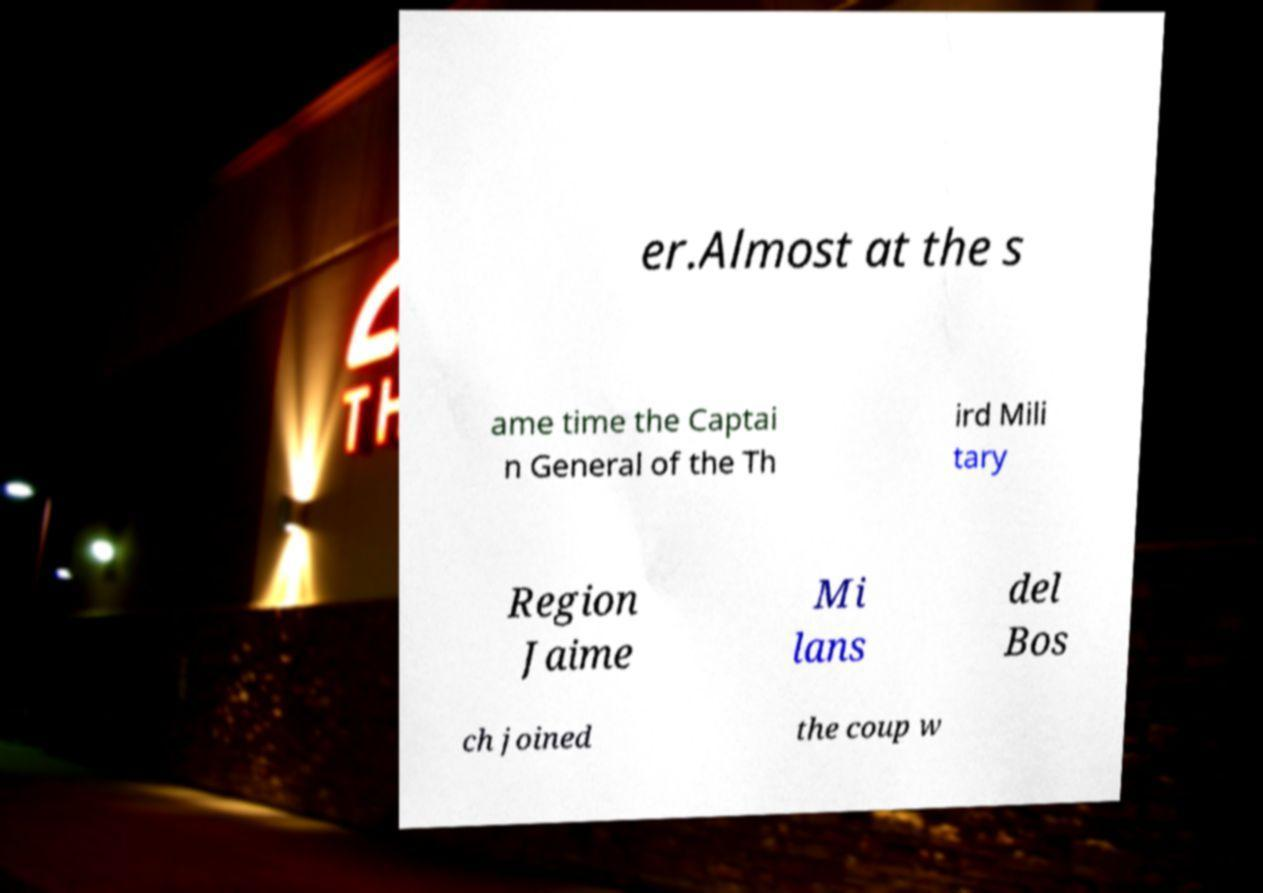I need the written content from this picture converted into text. Can you do that? er.Almost at the s ame time the Captai n General of the Th ird Mili tary Region Jaime Mi lans del Bos ch joined the coup w 